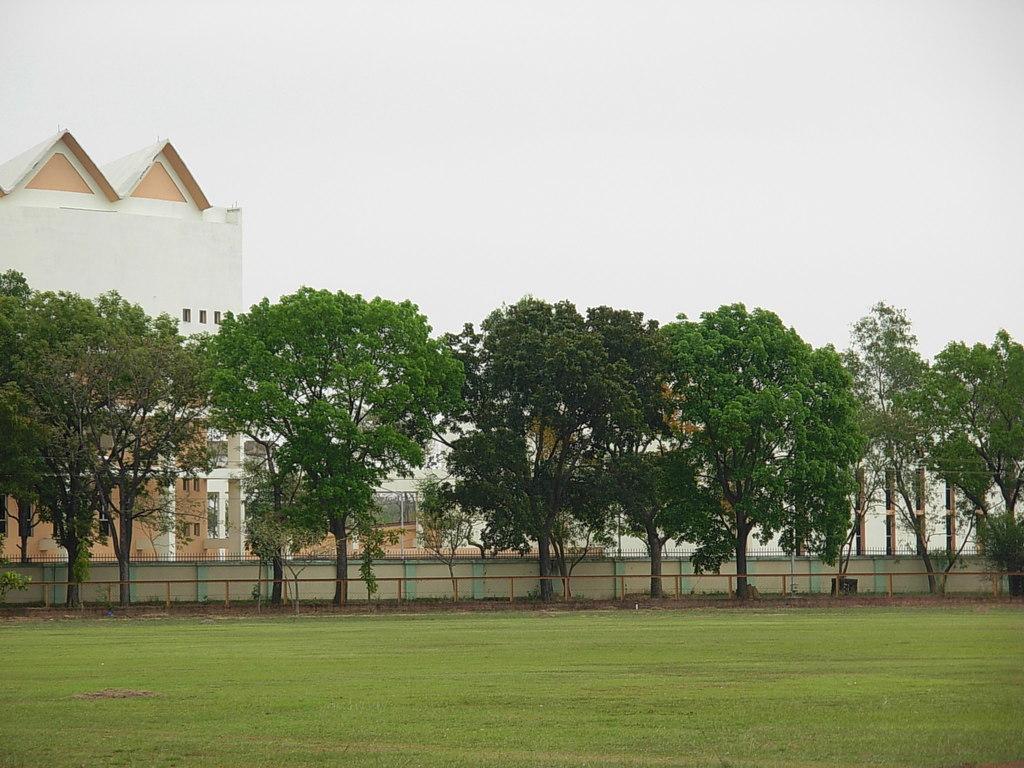Please provide a concise description of this image. In the image there is a garden and behind a garden there are many trees and there is a wall behind those trees, behind the wall there is a building. 